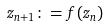<formula> <loc_0><loc_0><loc_500><loc_500>z _ { n + 1 } \colon = f ( z _ { n } )</formula> 